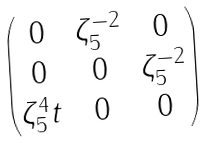Convert formula to latex. <formula><loc_0><loc_0><loc_500><loc_500>\begin{pmatrix} 0 & \zeta _ { 5 } ^ { - 2 } & 0 \\ 0 & 0 & \zeta _ { 5 } ^ { - 2 } \\ \zeta _ { 5 } ^ { 4 } t & 0 & 0 \end{pmatrix}</formula> 